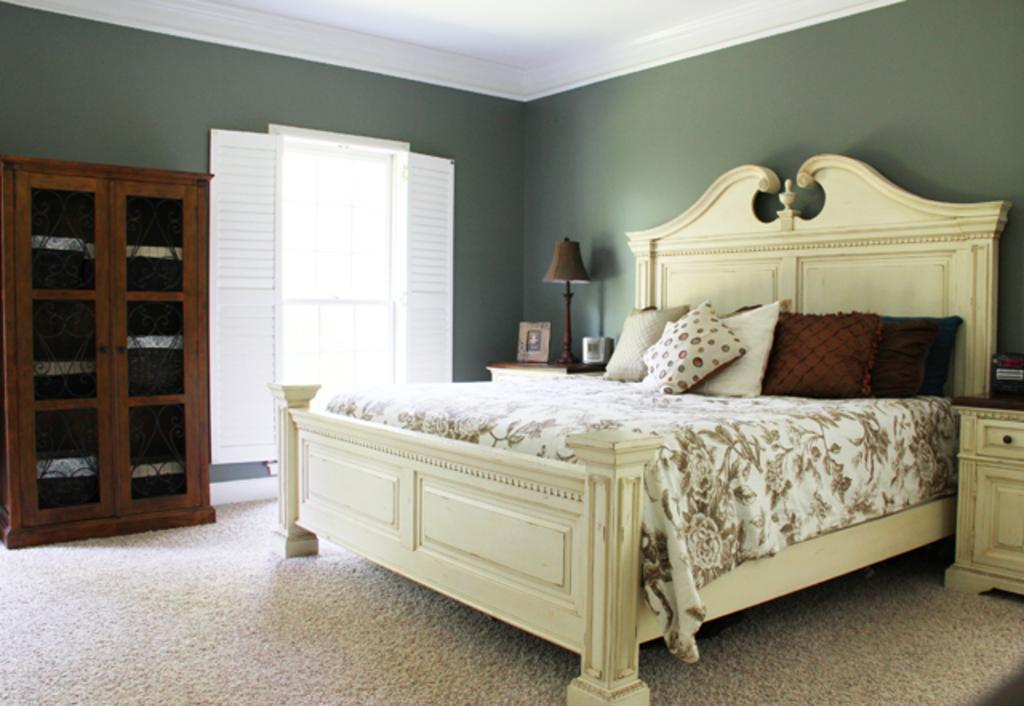What piece of paper can be seen on the cot in the image? There is no piece of paper visible on the cot in the image. What type of furniture is against the wall in the image? There is a cupboard against the wall in the image. What is the purpose of the pillow on the cot? The pillow on the cot is likely for providing support and comfort while sleeping or resting. What can be seen in the background of the image? In the background, there is a lamp placed on a table and a door. Can you see any vegetables growing on the cot in the image? There are no vegetables growing on the cot in the image. Is there a ship visible in the background of the image? There is no ship present in the image. 